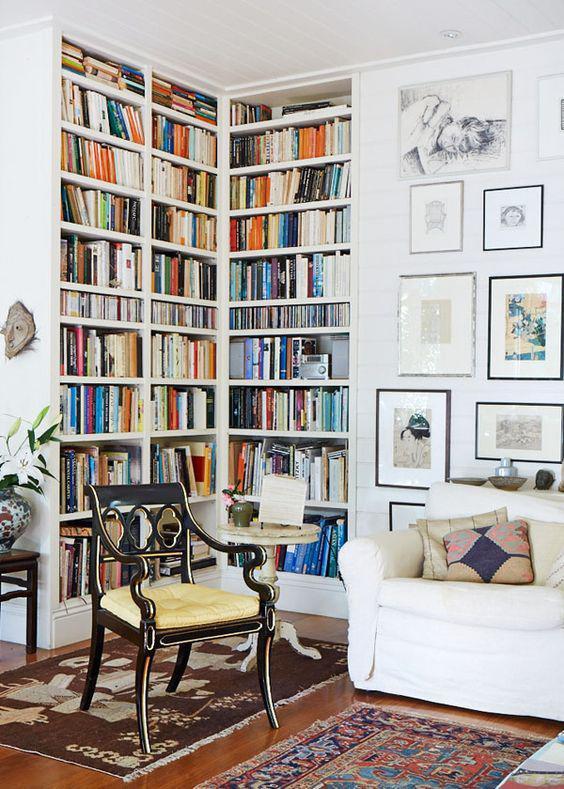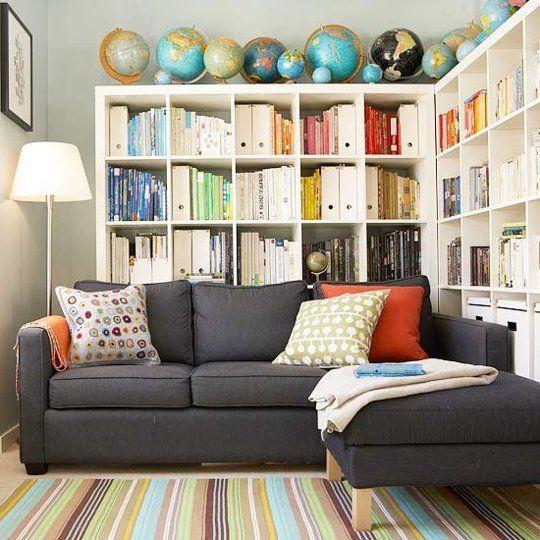The first image is the image on the left, the second image is the image on the right. Assess this claim about the two images: "A bookshelf sits behind a dark colored couch in the image on the right.". Correct or not? Answer yes or no. Yes. The first image is the image on the left, the second image is the image on the right. Evaluate the accuracy of this statement regarding the images: "The white bookshelves in one image are floor to ceiling, while those in the second image stop short of the ceiling and have decorative items displayed on top.". Is it true? Answer yes or no. Yes. 